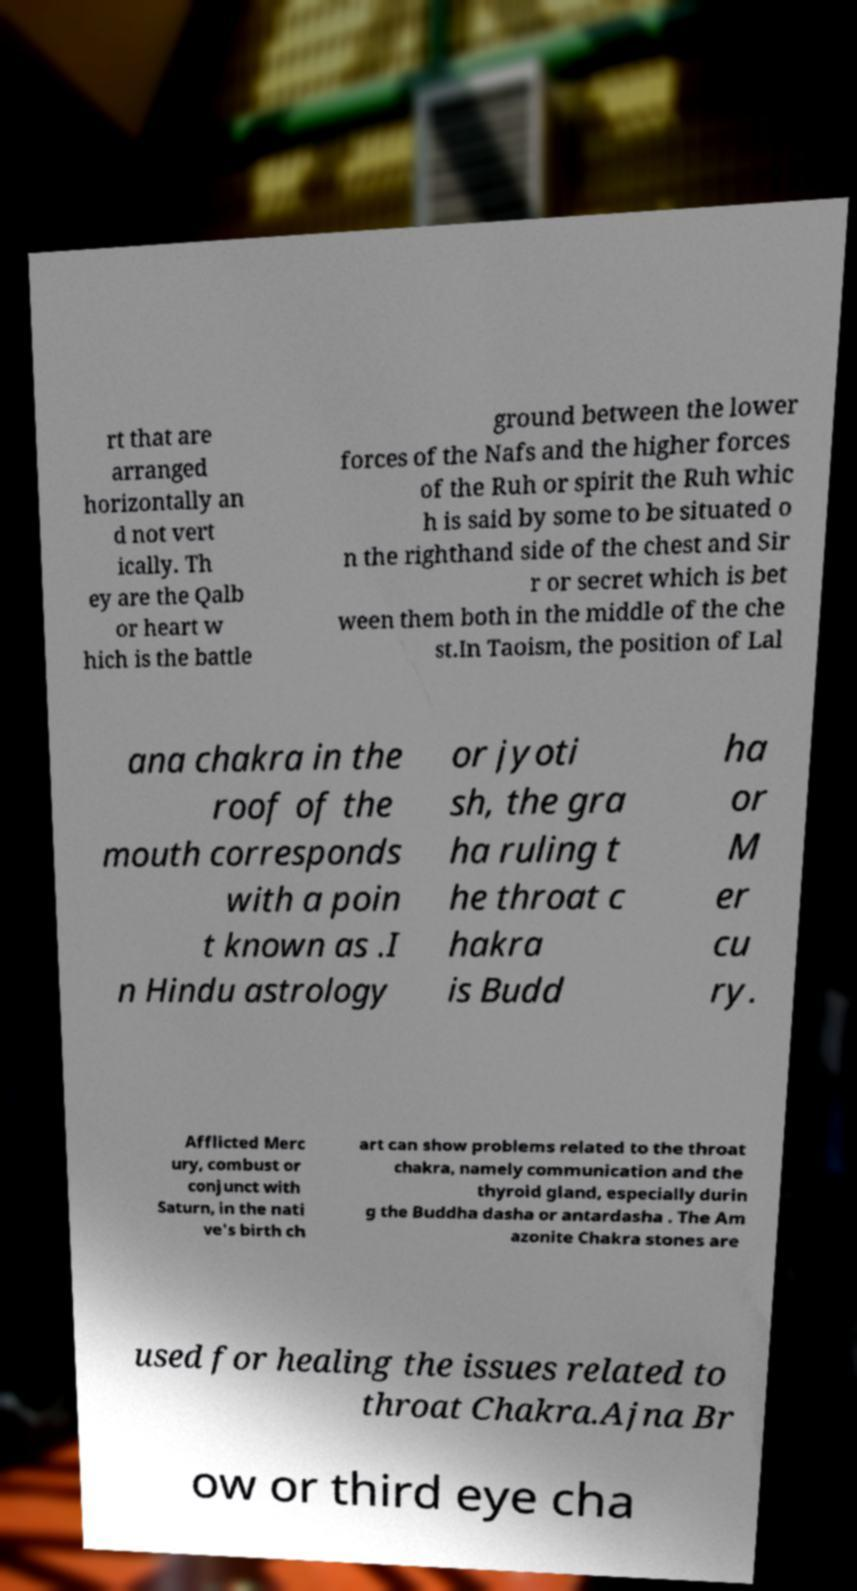Could you extract and type out the text from this image? rt that are arranged horizontally an d not vert ically. Th ey are the Qalb or heart w hich is the battle ground between the lower forces of the Nafs and the higher forces of the Ruh or spirit the Ruh whic h is said by some to be situated o n the righthand side of the chest and Sir r or secret which is bet ween them both in the middle of the che st.In Taoism, the position of Lal ana chakra in the roof of the mouth corresponds with a poin t known as .I n Hindu astrology or jyoti sh, the gra ha ruling t he throat c hakra is Budd ha or M er cu ry. Afflicted Merc ury, combust or conjunct with Saturn, in the nati ve's birth ch art can show problems related to the throat chakra, namely communication and the thyroid gland, especially durin g the Buddha dasha or antardasha . The Am azonite Chakra stones are used for healing the issues related to throat Chakra.Ajna Br ow or third eye cha 